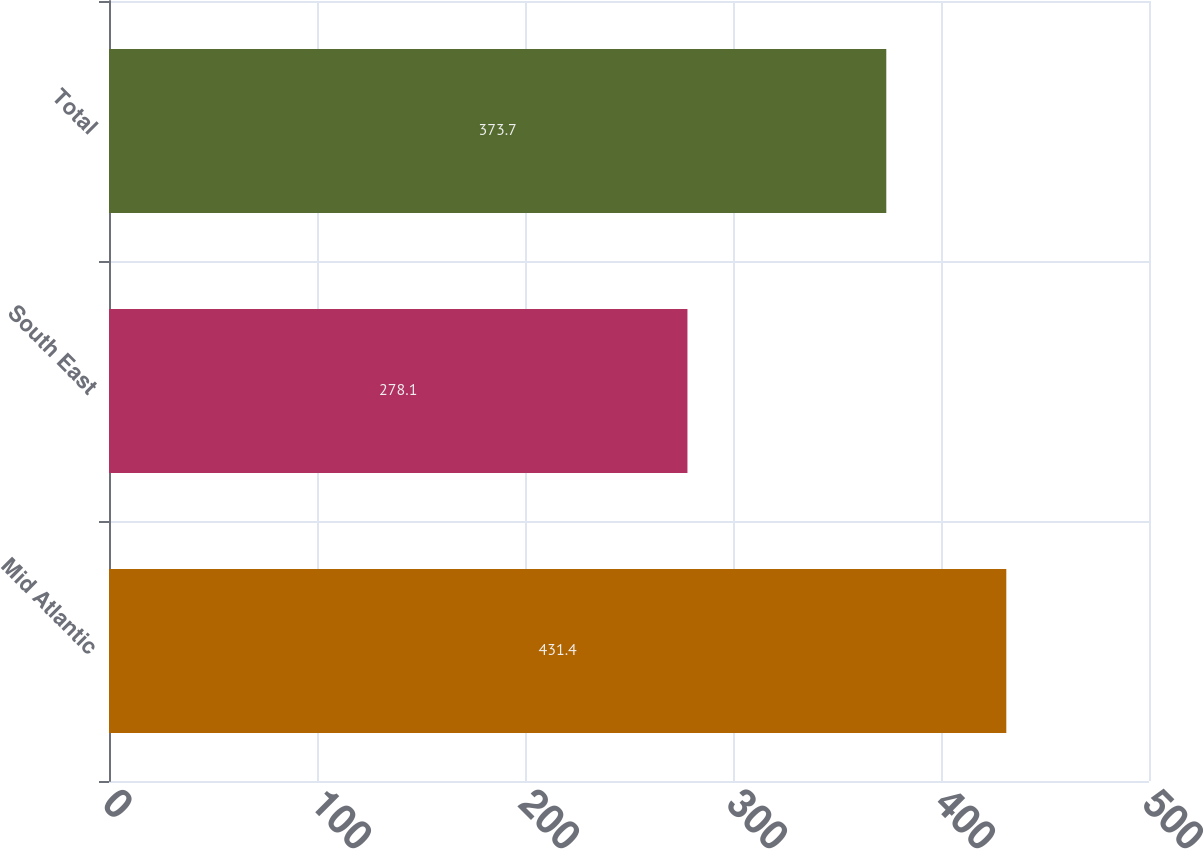Convert chart to OTSL. <chart><loc_0><loc_0><loc_500><loc_500><bar_chart><fcel>Mid Atlantic<fcel>South East<fcel>Total<nl><fcel>431.4<fcel>278.1<fcel>373.7<nl></chart> 